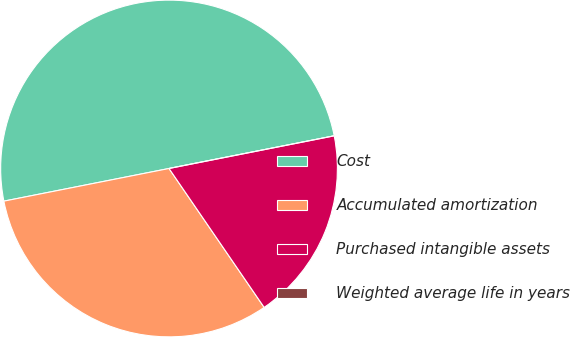Convert chart. <chart><loc_0><loc_0><loc_500><loc_500><pie_chart><fcel>Cost<fcel>Accumulated amortization<fcel>Purchased intangible assets<fcel>Weighted average life in years<nl><fcel>50.0%<fcel>31.45%<fcel>18.55%<fcel>0.0%<nl></chart> 